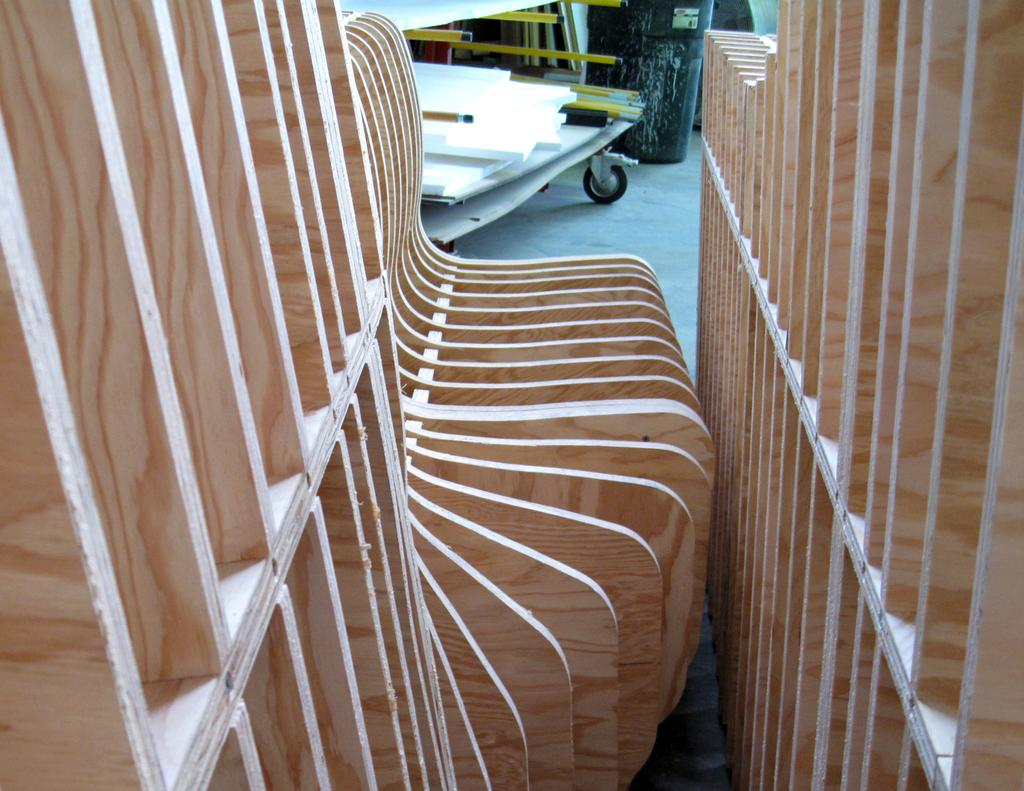What type of structure is present in the image? There is a wooden rack in the image. What is stored inside the wooden rack? There is a trolley in the wooden rack. What material is used for the rods in the trolley? The rods in the trolley are made of metal. What can be seen on the ground beside the wooden rack? There is an object on the ground beside the wooden rack. How does the expert rate the hotness of the object on the ground beside the wooden rack? There is no expert or hotness rating mentioned in the image. The image only shows a wooden rack, a trolley, metal rods, and an object on the ground. 